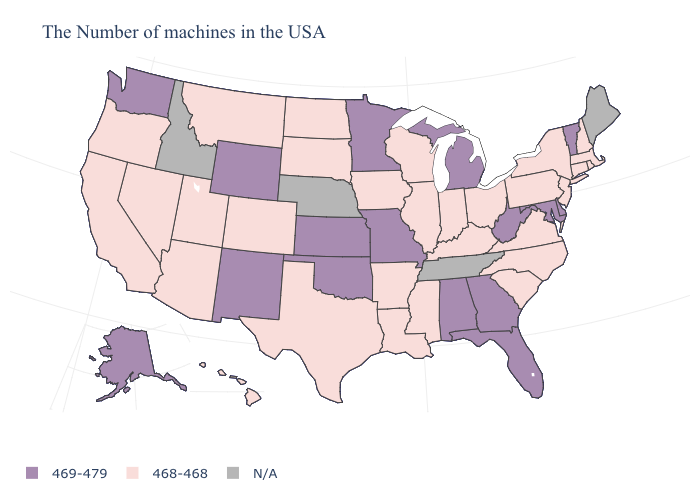Name the states that have a value in the range N/A?
Keep it brief. Maine, Tennessee, Nebraska, Idaho. What is the lowest value in the MidWest?
Concise answer only. 468-468. Name the states that have a value in the range 469-479?
Write a very short answer. Vermont, Delaware, Maryland, West Virginia, Florida, Georgia, Michigan, Alabama, Missouri, Minnesota, Kansas, Oklahoma, Wyoming, New Mexico, Washington, Alaska. What is the value of Montana?
Short answer required. 468-468. Name the states that have a value in the range N/A?
Short answer required. Maine, Tennessee, Nebraska, Idaho. Name the states that have a value in the range N/A?
Give a very brief answer. Maine, Tennessee, Nebraska, Idaho. Among the states that border Georgia , does South Carolina have the highest value?
Quick response, please. No. Does Oklahoma have the lowest value in the South?
Quick response, please. No. Does Connecticut have the highest value in the Northeast?
Answer briefly. No. Does the first symbol in the legend represent the smallest category?
Be succinct. No. Name the states that have a value in the range N/A?
Give a very brief answer. Maine, Tennessee, Nebraska, Idaho. What is the highest value in the USA?
Keep it brief. 469-479. 